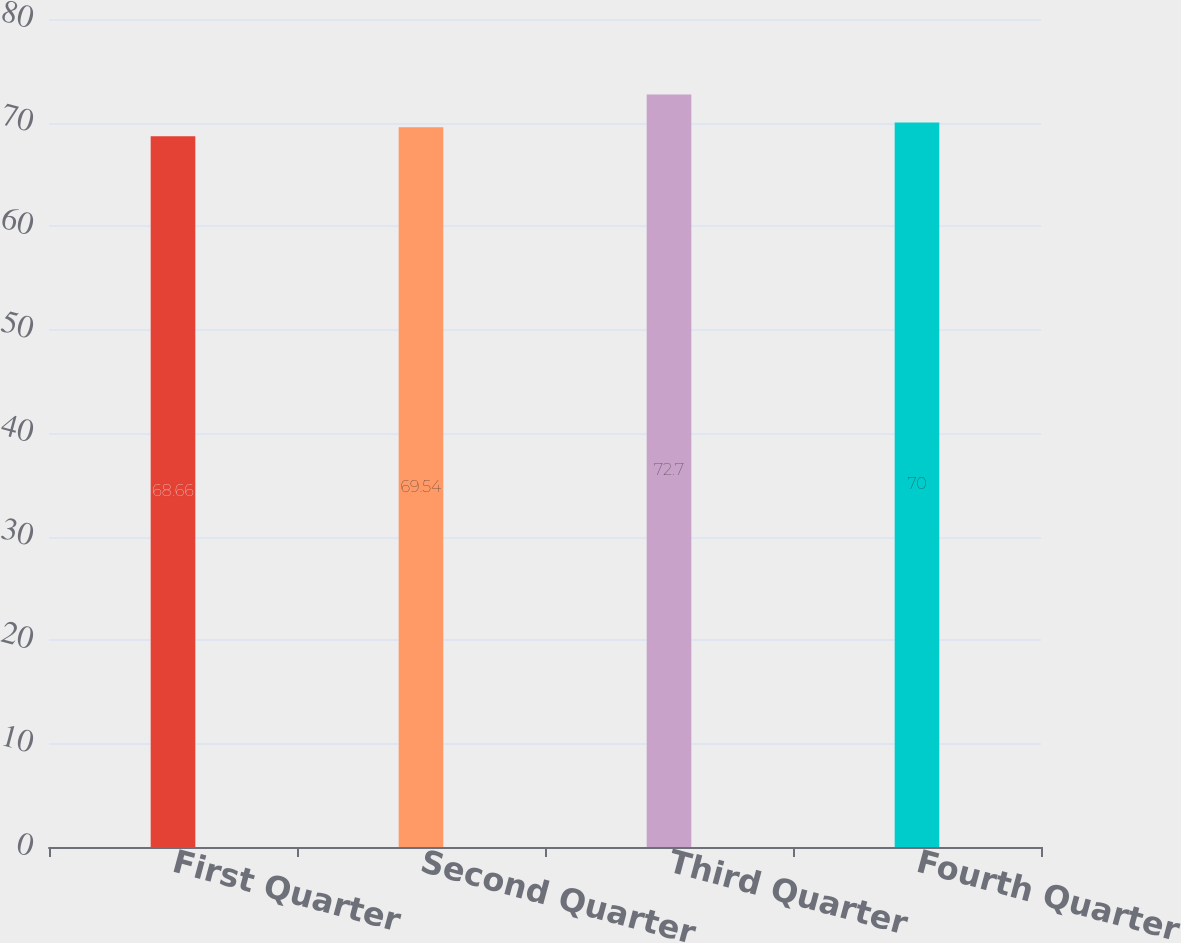Convert chart. <chart><loc_0><loc_0><loc_500><loc_500><bar_chart><fcel>First Quarter<fcel>Second Quarter<fcel>Third Quarter<fcel>Fourth Quarter<nl><fcel>68.66<fcel>69.54<fcel>72.7<fcel>70<nl></chart> 